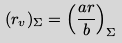Convert formula to latex. <formula><loc_0><loc_0><loc_500><loc_500>( r _ { v } ) _ { \Sigma } = \left ( \frac { a r } { b } \right ) _ { \Sigma }</formula> 